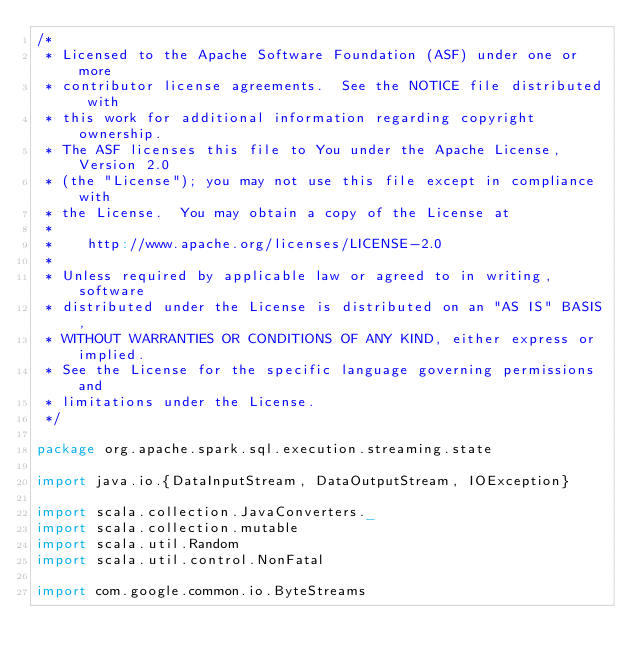<code> <loc_0><loc_0><loc_500><loc_500><_Scala_>/*
 * Licensed to the Apache Software Foundation (ASF) under one or more
 * contributor license agreements.  See the NOTICE file distributed with
 * this work for additional information regarding copyright ownership.
 * The ASF licenses this file to You under the Apache License, Version 2.0
 * (the "License"); you may not use this file except in compliance with
 * the License.  You may obtain a copy of the License at
 *
 *    http://www.apache.org/licenses/LICENSE-2.0
 *
 * Unless required by applicable law or agreed to in writing, software
 * distributed under the License is distributed on an "AS IS" BASIS,
 * WITHOUT WARRANTIES OR CONDITIONS OF ANY KIND, either express or implied.
 * See the License for the specific language governing permissions and
 * limitations under the License.
 */

package org.apache.spark.sql.execution.streaming.state

import java.io.{DataInputStream, DataOutputStream, IOException}

import scala.collection.JavaConverters._
import scala.collection.mutable
import scala.util.Random
import scala.util.control.NonFatal

import com.google.common.io.ByteStreams</code> 